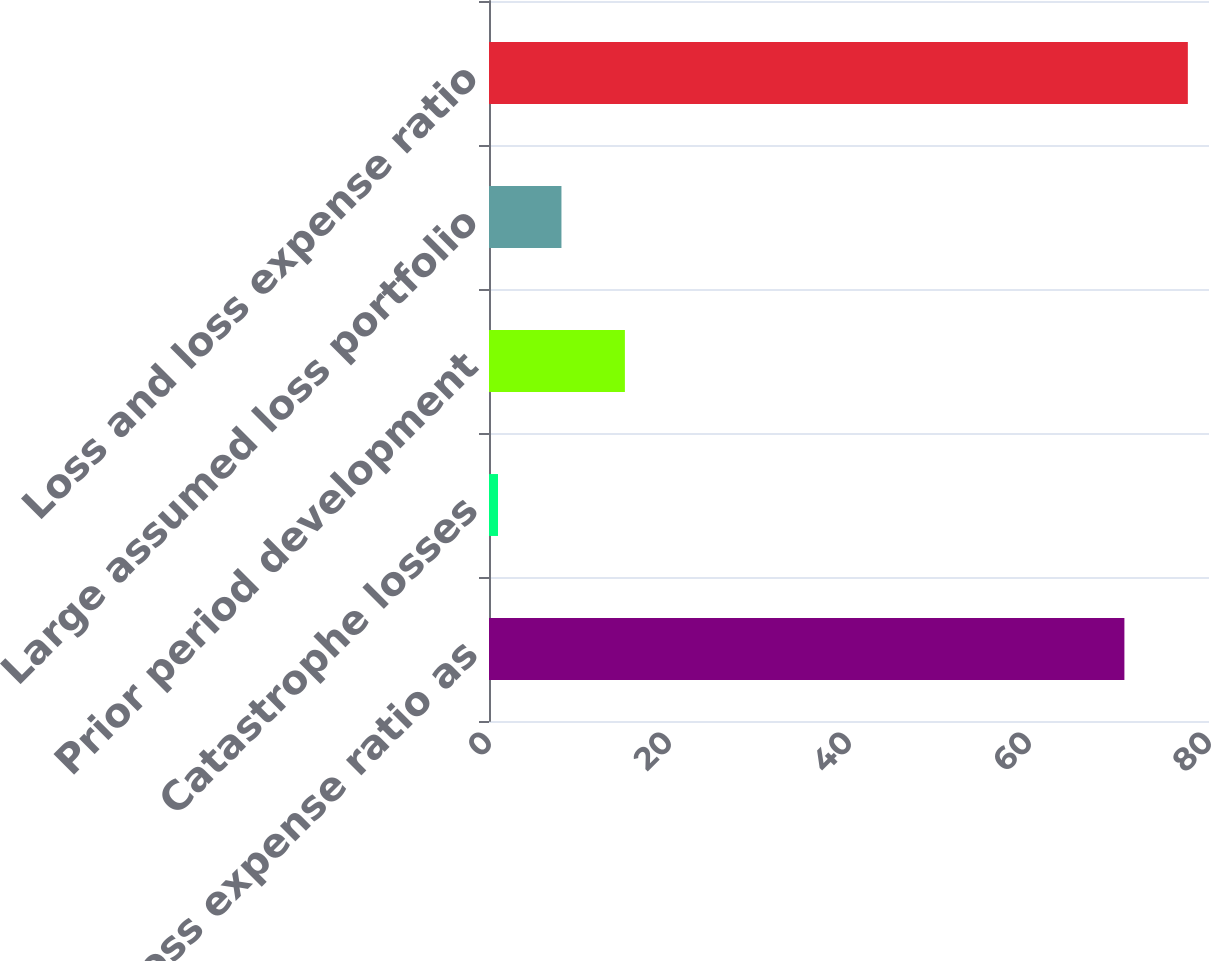Convert chart to OTSL. <chart><loc_0><loc_0><loc_500><loc_500><bar_chart><fcel>Loss and loss expense ratio as<fcel>Catastrophe losses<fcel>Prior period development<fcel>Large assumed loss portfolio<fcel>Loss and loss expense ratio<nl><fcel>70.6<fcel>1<fcel>15.1<fcel>8.05<fcel>77.65<nl></chart> 